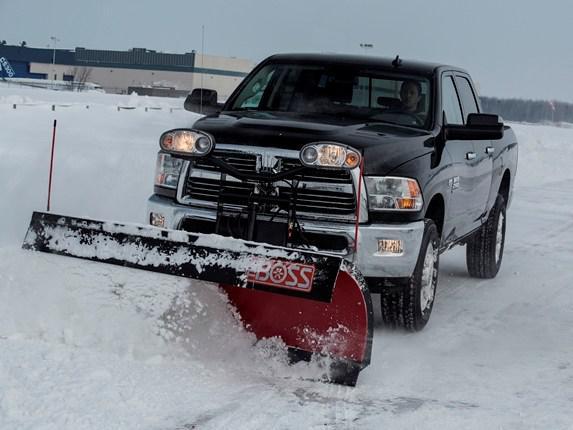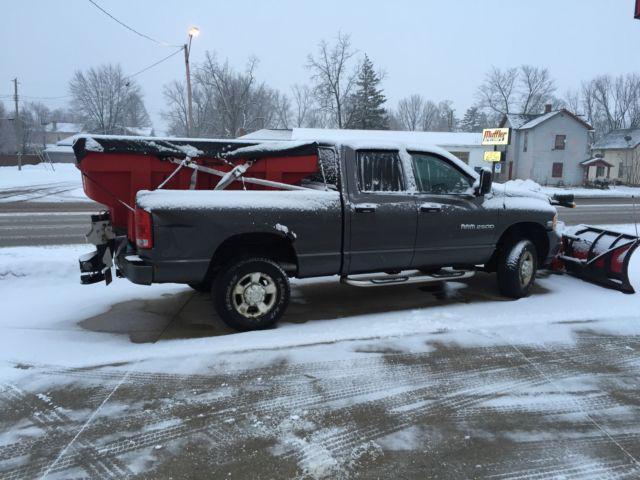The first image is the image on the left, the second image is the image on the right. Evaluate the accuracy of this statement regarding the images: "One image features a rightward-facing truck with a plow on its front, parked on dry pavement with no snow in sight.". Is it true? Answer yes or no. No. The first image is the image on the left, the second image is the image on the right. For the images displayed, is the sentence "The left and right image contains the same number of black trucks with a plow." factually correct? Answer yes or no. Yes. 